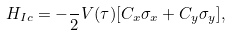<formula> <loc_0><loc_0><loc_500><loc_500>H _ { I c } = - \frac { } { 2 } V ( \tau ) [ C _ { x } \sigma _ { x } + C _ { y } \sigma _ { y } ] ,</formula> 